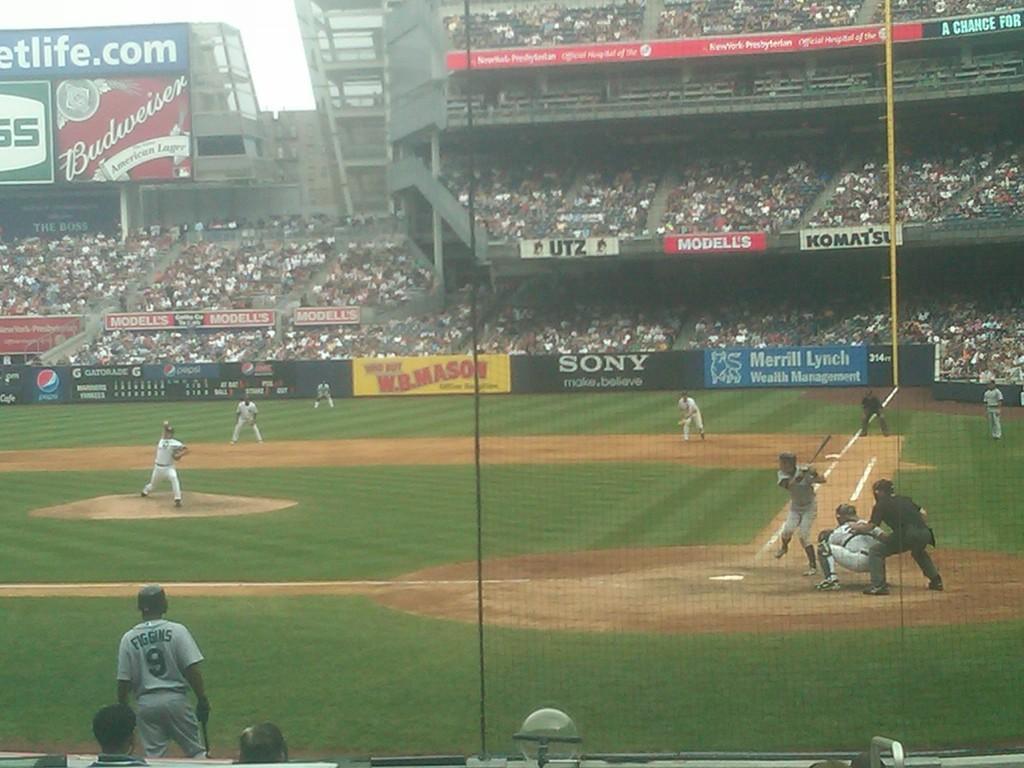Please provide a concise description of this image. In this picture we can see grass and ground. These are players. In the background of the image we can see stadium, people, hoardings, boards, pole and sky. At the bottom of the image we can see person's head and objects. 